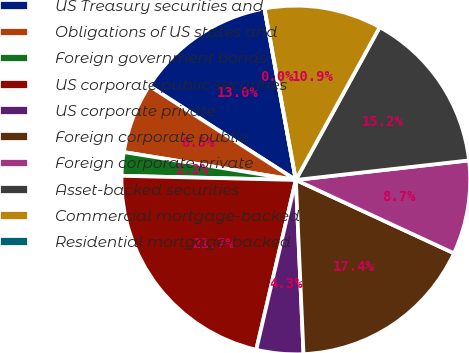<chart> <loc_0><loc_0><loc_500><loc_500><pie_chart><fcel>US Treasury securities and<fcel>Obligations of US states and<fcel>Foreign government bonds<fcel>US corporate public securities<fcel>US corporate private<fcel>Foreign corporate public<fcel>Foreign corporate private<fcel>Asset-backed securities<fcel>Commercial mortgage-backed<fcel>Residential mortgage-backed<nl><fcel>13.04%<fcel>6.52%<fcel>2.18%<fcel>21.73%<fcel>4.35%<fcel>17.39%<fcel>8.7%<fcel>15.22%<fcel>10.87%<fcel>0.0%<nl></chart> 